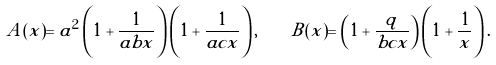<formula> <loc_0><loc_0><loc_500><loc_500>A ( x ) = a ^ { 2 } \left ( 1 + \frac { 1 } { a b x } \right ) \left ( 1 + \frac { 1 } { a c x } \right ) , \quad B ( x ) = \left ( 1 + \frac { q } { b c x } \right ) \left ( 1 + \frac { 1 } { x } \right ) .</formula> 